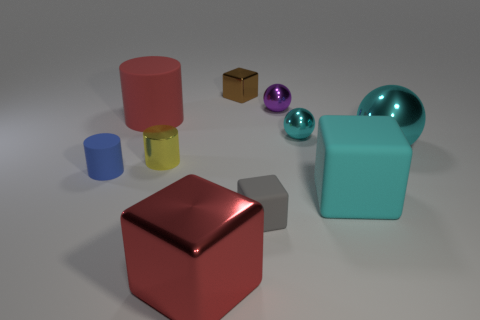Subtract all tiny yellow cylinders. How many cylinders are left? 2 Subtract 1 red cylinders. How many objects are left? 9 Subtract all cubes. How many objects are left? 6 Subtract 3 cubes. How many cubes are left? 1 Subtract all blue balls. Subtract all purple cubes. How many balls are left? 3 Subtract all cyan blocks. How many red spheres are left? 0 Subtract all tiny gray blocks. Subtract all big red rubber cylinders. How many objects are left? 8 Add 9 big red metal objects. How many big red metal objects are left? 10 Add 1 spheres. How many spheres exist? 4 Subtract all yellow cylinders. How many cylinders are left? 2 